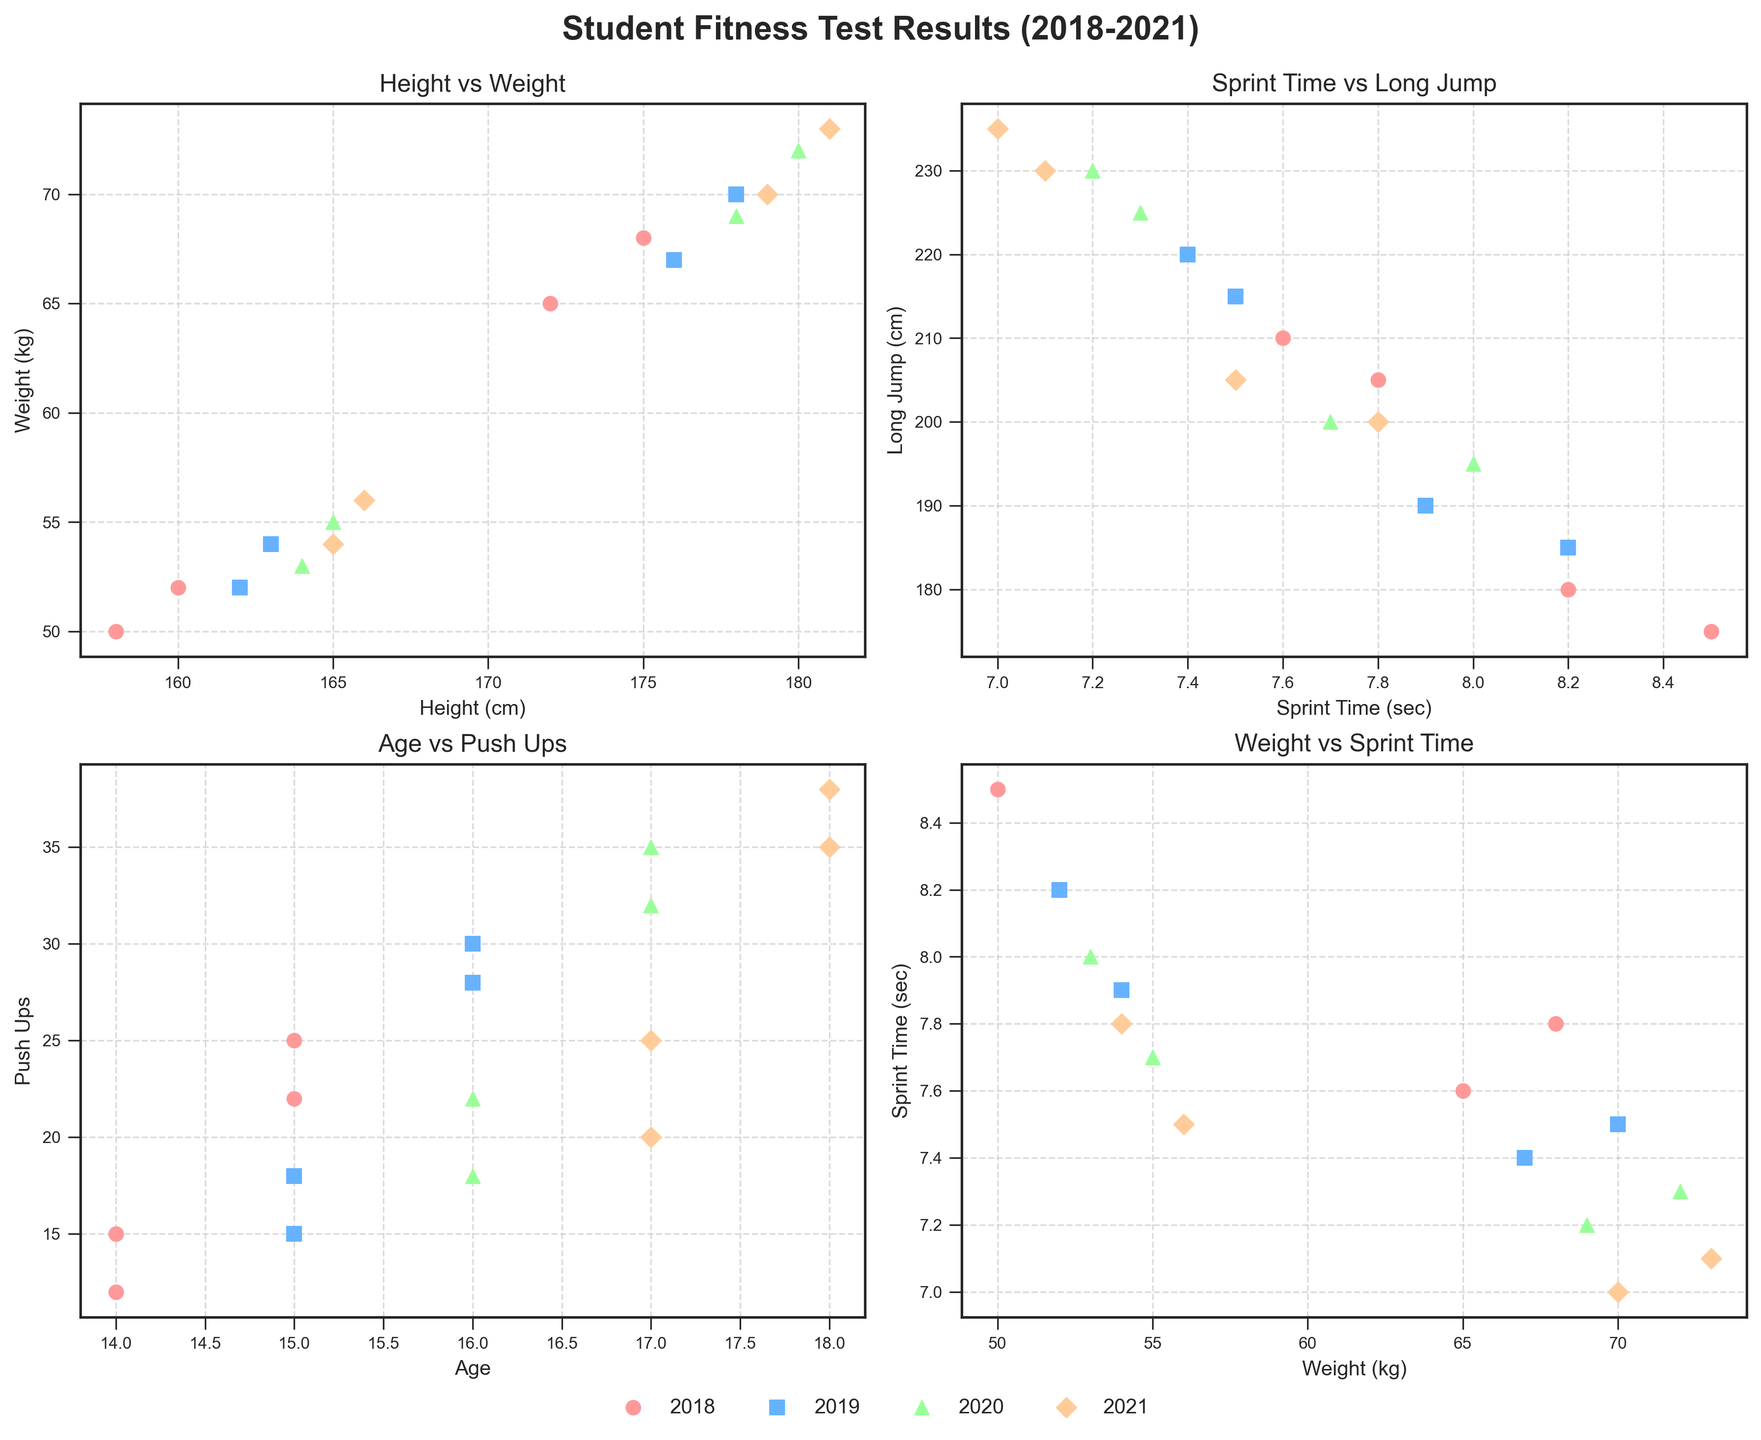What is the title of the figure? The title of the figure is typically placed at the top, and according to the provided code it is set using `fig.suptitle`. The title reads "Student Fitness Test Results (2018-2021)".
Answer: Student Fitness Test Results (2018-2021) Which subplot shows the relationship between height and weight? The subplots are defined within the `axs` array in a 2x2 grid. The top-left subplot (axs[0, 0]) is labeled with the x-axis "Height (cm)" and the y-axis "Weight (kg)". The title of this subplot is "Height vs Weight".
Answer: Top-left How many students are represented in the 2020 subplot for Sprint Time vs Long Jump? In each year, based on the data provided, there are four students. The subplot showing Sprint Time vs Long Jump is the top-right subplot (axs[0, 1]). Thus, for the year 2020, it plots 4 data points.
Answer: 4 Which subplot would you look at to study changes in Push Ups over ages? The subplot showing the relationship between Age and Push Ups is the bottom-left subplot (axs[1, 0]). Here, the x-axis is labeled "Age" and the y-axis is labeled "Push Ups".
Answer: Bottom-left In which year were the highest number of push-ups recorded, and by whom? To find the highest number of push-ups, look at the Age vs Push Ups subplot (bottom-left). The highest number of push-ups is marked for the year 2021 for Michael Lee, plotted using distinct colors for each year.
Answer: 2021, Michael Lee Compare the Sprint Time for Emma Thompson and Michael Lee in 2021. Who was faster? By examining the data points in the bottom-right subplot (Weight vs Sprint Time) for the year 2021, Emma Thompson's sprint time was 7.5 seconds, and Michael Lee's was 7.0 seconds. Thus, Michael Lee was faster.
Answer: Michael Lee What is the trend in the long jump results as the years progress? To identify the trend in Long Jump results over the years, look at the top-right subplot (Sprint Time vs Long Jump). The data points for each year show that generally, Long Jump distances increase over the years.
Answer: Generally increasing Did the weight of students consistently increase over the years? Observing the top-left subplot (Height vs Weight), the legend helps identify the years. As the years progress from 2018 to 2021, the weights of students show an increasing trend with minor exceptions.
Answer: Generally yes, with minor exceptions How are Sprint Time and Long Jump correlated based on the subplot? Examining the top-right subplot (Sprint Time vs Long Jump), there appears to be a negative correlation, as lower sprint times generally correspond to longer jump distances.
Answer: Negatively correlated What can you infer about the relationship between weight and sprint time? The bottom-right subplot (Weight vs Sprint Time) shows that as weight increases, sprint time tends to decrease, indicating that heavier students often run faster sprints.
Answer: Heavier students run faster 